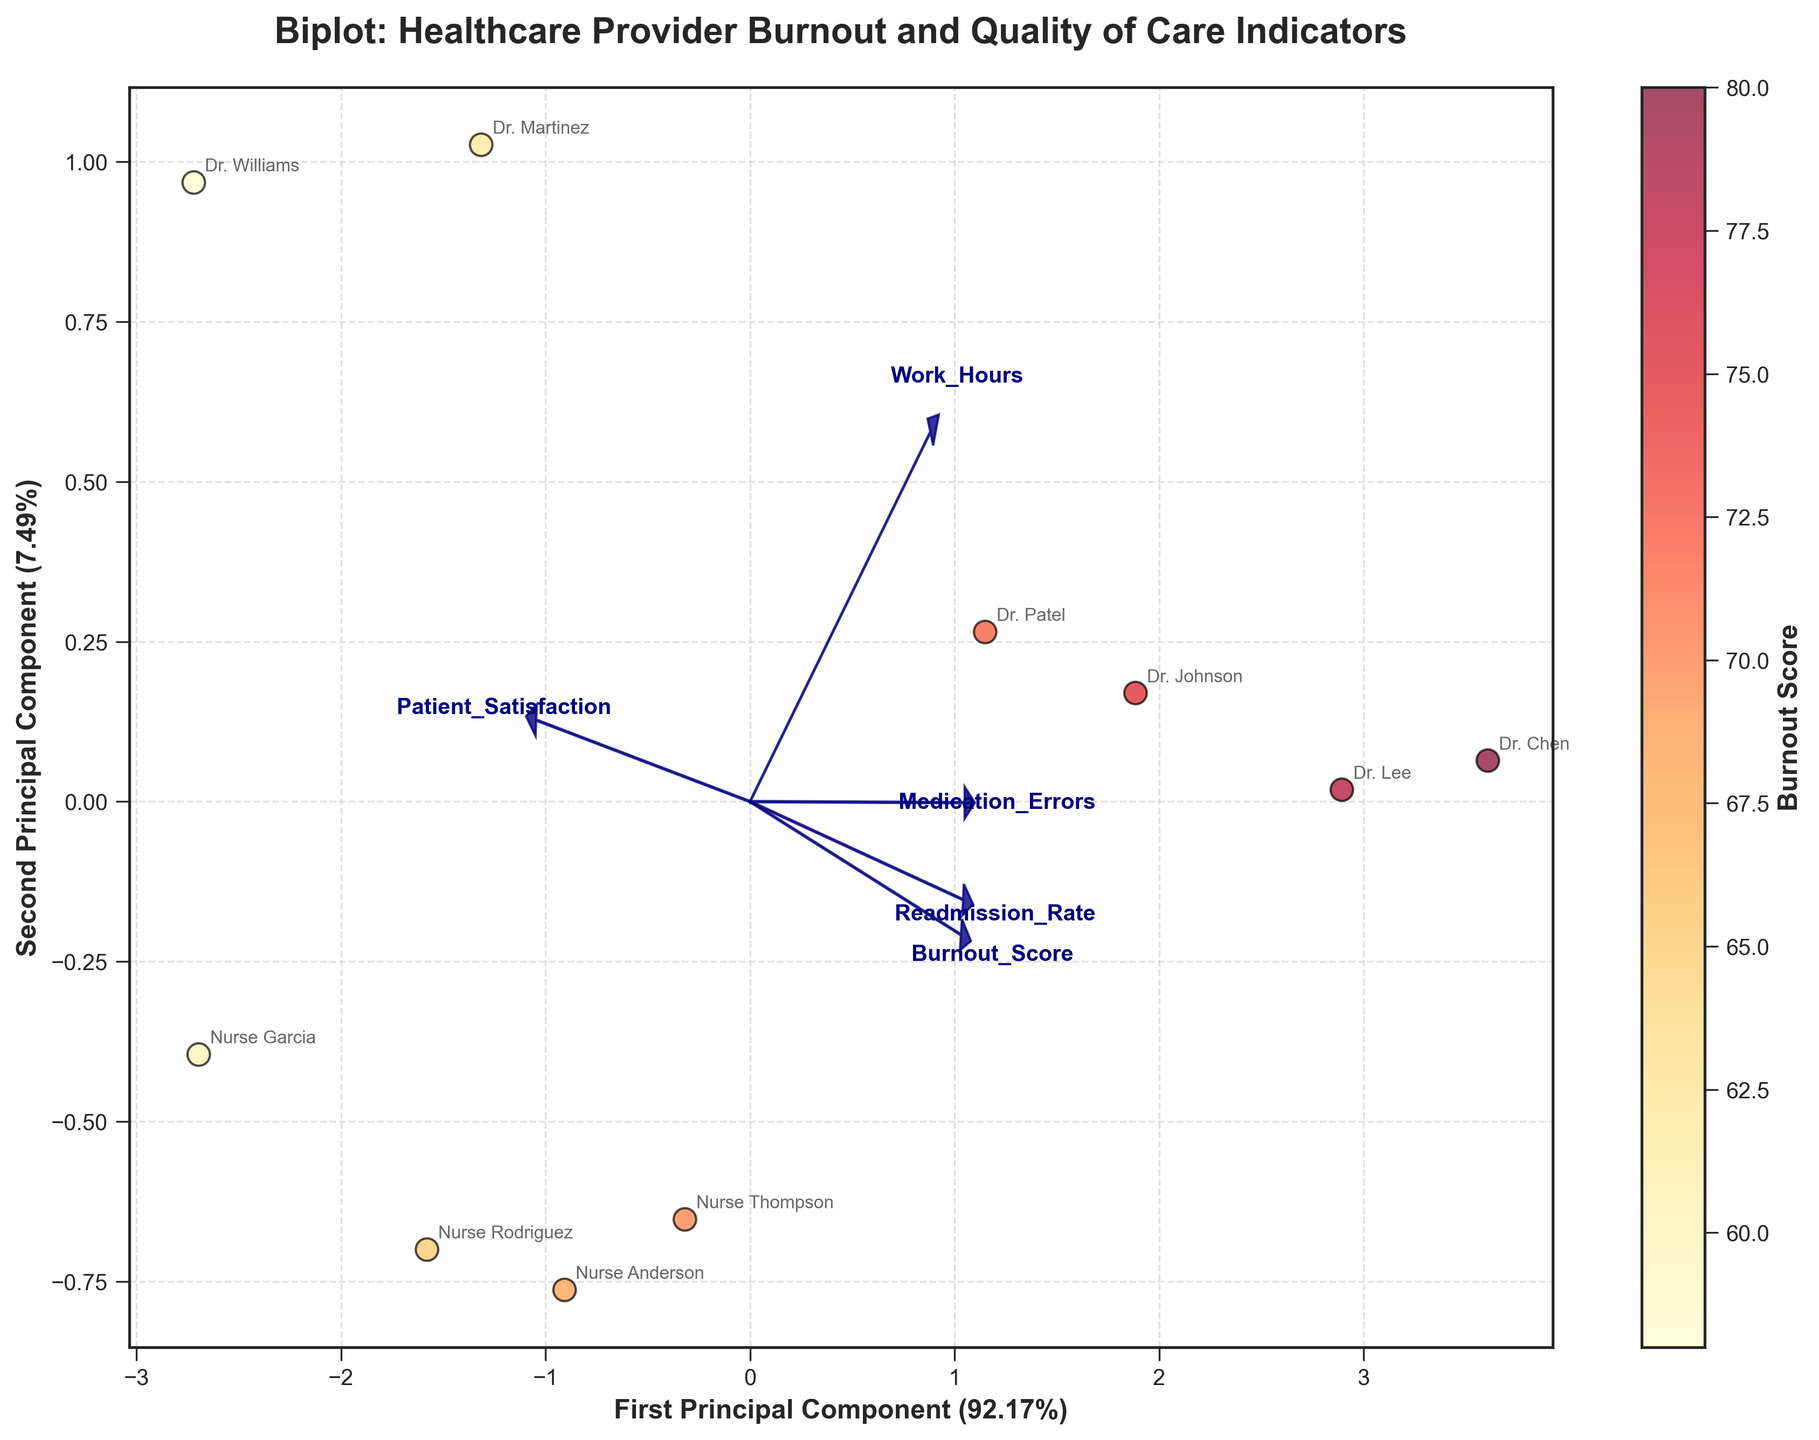What is the title of the plot? The title is written at the top of the plot.
Answer: Biplot: Healthcare Provider Burnout and Quality of Care Indicators How many principal components are labeled on the axes? The x and y axes are labeled with the principal components, each showing the explained variance percentage.
Answer: Two Which provider has the highest Burnout Score on the plot? The data points are color-coded by Burnout Scores, and the legend shows that darker red represents higher scores. By looking at the color gradient, identify the darkest point.
Answer: Dr. Chen What does the arrow labeled 'Patient_Satisfaction' indicate? Arrows in a biplot point in the direction of increasing values for that feature. The length of the arrow signifies the relative importance and contribution of that feature to the principal components.
Answer: It indicates the direction and importance of increasing Patient Satisfaction in relation to the components Which two features have loading vectors pointing in almost opposite directions? Loading vectors are depicted as arrows. Opposite directions imply that the features negatively correlate with each other.
Answer: Medication Errors and Patient Satisfaction What is the rough range of Burnout Scores seen in this plot? The color gradient on the scatter points represents the Burnout Scores, and the color bar indicates the range. Observing these can provide the approximate range.
Answer: 58 to 80 Which provider is located closest to the origin in the two-dimensional PCA space? Look for the scatter point closest to where the x and y axes intersect (origin).
Answer: Nurse Rodriguez Comparing 'Dr. Johnson' and 'Dr. Williams', which provider appears to have a higher Work Hours based on their position in the PCA plot? Work Hours can be inferred by the contribution direction of its loading vector in the principal component space. Compare the positions of the two providers relative to this vector.
Answer: Dr. Johnson How is 'Readmission_Rate' related to 'Burnout_Score' in the PCA plot? Look at the angles between the vectors: a small angle indicates a positive correlation, while a large angle (approaching 180 degrees) indicates a negative correlation.
Answer: Positively correlated Which two features could be considered most influential for the first principal component? The influence can be judged by the arrow lengths of loading vectors along the first principal component's axis. Longer arrows indicate higher influence.
Answer: Burnout Score and Work Hours 